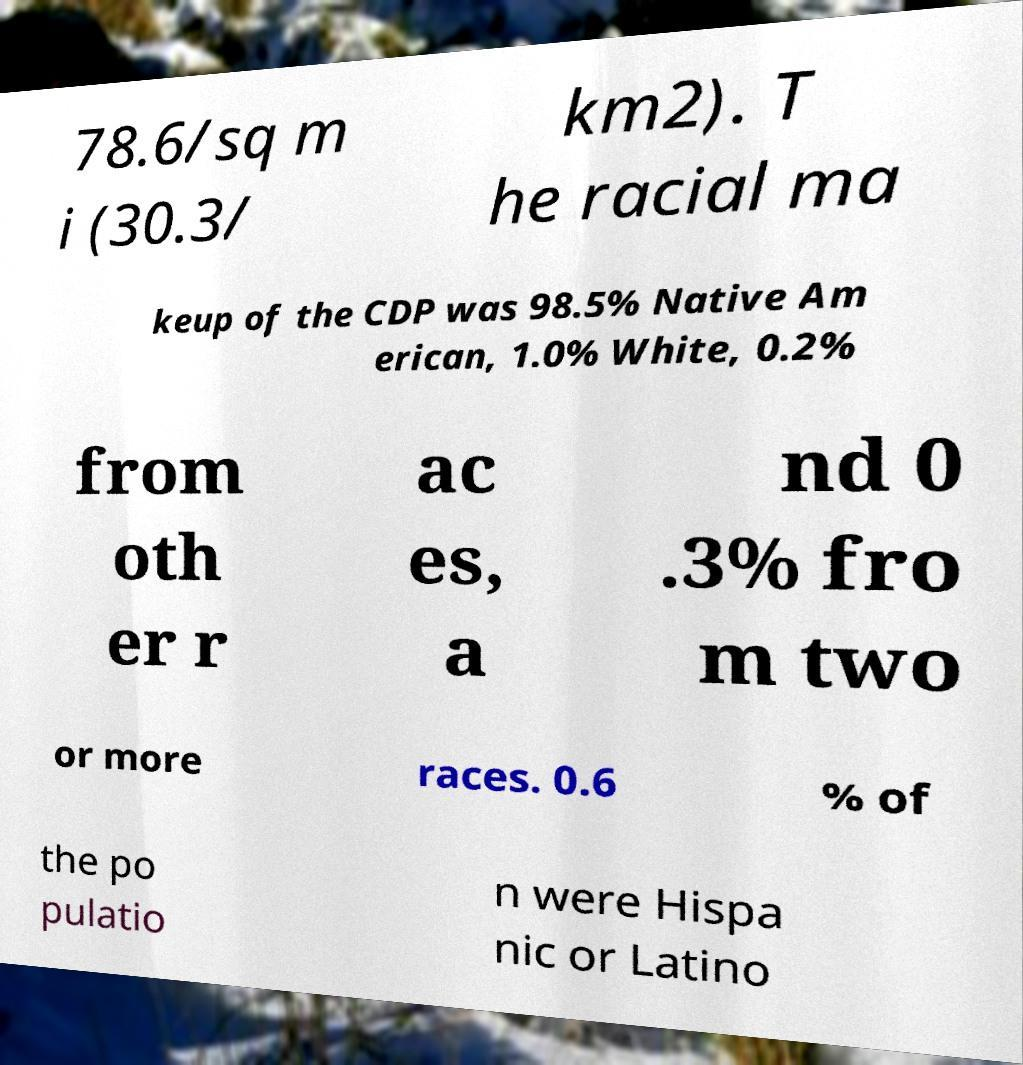Can you read and provide the text displayed in the image?This photo seems to have some interesting text. Can you extract and type it out for me? 78.6/sq m i (30.3/ km2). T he racial ma keup of the CDP was 98.5% Native Am erican, 1.0% White, 0.2% from oth er r ac es, a nd 0 .3% fro m two or more races. 0.6 % of the po pulatio n were Hispa nic or Latino 